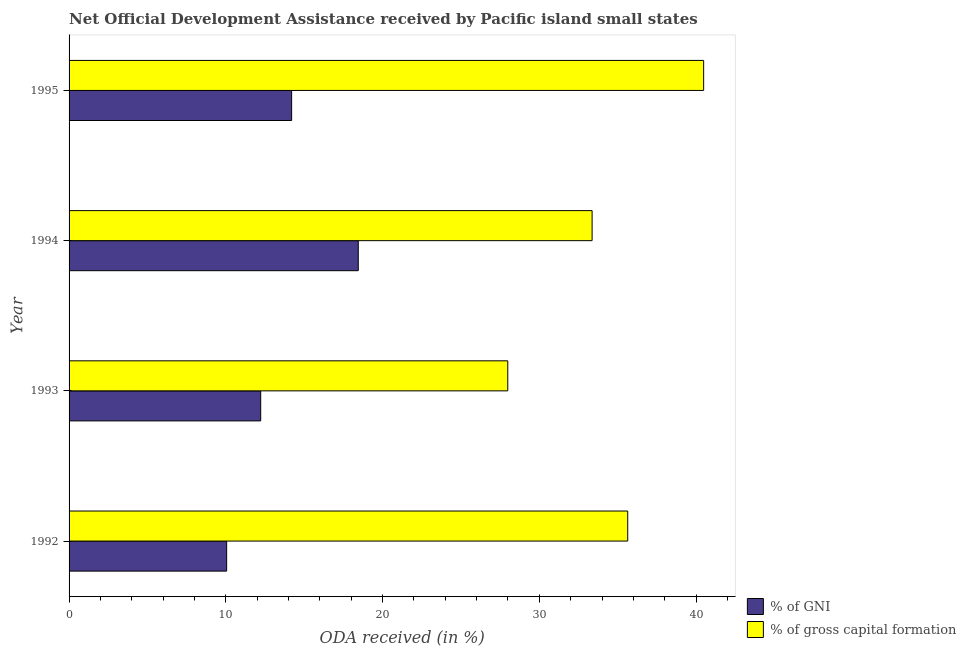How many groups of bars are there?
Your response must be concise. 4. How many bars are there on the 4th tick from the bottom?
Offer a terse response. 2. What is the label of the 1st group of bars from the top?
Offer a terse response. 1995. What is the oda received as percentage of gni in 1993?
Make the answer very short. 12.23. Across all years, what is the maximum oda received as percentage of gni?
Provide a short and direct response. 18.45. Across all years, what is the minimum oda received as percentage of gni?
Your answer should be compact. 10.05. In which year was the oda received as percentage of gross capital formation maximum?
Make the answer very short. 1995. In which year was the oda received as percentage of gross capital formation minimum?
Make the answer very short. 1993. What is the total oda received as percentage of gross capital formation in the graph?
Make the answer very short. 137.48. What is the difference between the oda received as percentage of gross capital formation in 1993 and that in 1995?
Your answer should be very brief. -12.5. What is the difference between the oda received as percentage of gross capital formation in 1995 and the oda received as percentage of gni in 1993?
Keep it short and to the point. 28.26. What is the average oda received as percentage of gni per year?
Provide a succinct answer. 13.73. In the year 1993, what is the difference between the oda received as percentage of gni and oda received as percentage of gross capital formation?
Your answer should be compact. -15.76. In how many years, is the oda received as percentage of gni greater than 6 %?
Your answer should be compact. 4. What is the ratio of the oda received as percentage of gni in 1993 to that in 1994?
Provide a short and direct response. 0.66. Is the oda received as percentage of gni in 1992 less than that in 1993?
Your response must be concise. Yes. Is the difference between the oda received as percentage of gross capital formation in 1992 and 1993 greater than the difference between the oda received as percentage of gni in 1992 and 1993?
Make the answer very short. Yes. What is the difference between the highest and the second highest oda received as percentage of gross capital formation?
Offer a very short reply. 4.84. What is the difference between the highest and the lowest oda received as percentage of gross capital formation?
Your answer should be compact. 12.5. In how many years, is the oda received as percentage of gross capital formation greater than the average oda received as percentage of gross capital formation taken over all years?
Give a very brief answer. 2. Is the sum of the oda received as percentage of gni in 1993 and 1994 greater than the maximum oda received as percentage of gross capital formation across all years?
Give a very brief answer. No. What does the 1st bar from the top in 1993 represents?
Your response must be concise. % of gross capital formation. What does the 1st bar from the bottom in 1994 represents?
Your answer should be very brief. % of GNI. What is the title of the graph?
Offer a very short reply. Net Official Development Assistance received by Pacific island small states. What is the label or title of the X-axis?
Offer a terse response. ODA received (in %). What is the label or title of the Y-axis?
Make the answer very short. Year. What is the ODA received (in %) in % of GNI in 1992?
Provide a succinct answer. 10.05. What is the ODA received (in %) of % of gross capital formation in 1992?
Provide a succinct answer. 35.64. What is the ODA received (in %) in % of GNI in 1993?
Provide a succinct answer. 12.23. What is the ODA received (in %) in % of gross capital formation in 1993?
Make the answer very short. 27.99. What is the ODA received (in %) of % of GNI in 1994?
Keep it short and to the point. 18.45. What is the ODA received (in %) in % of gross capital formation in 1994?
Provide a short and direct response. 33.37. What is the ODA received (in %) of % of GNI in 1995?
Offer a terse response. 14.2. What is the ODA received (in %) of % of gross capital formation in 1995?
Provide a short and direct response. 40.48. Across all years, what is the maximum ODA received (in %) of % of GNI?
Your answer should be very brief. 18.45. Across all years, what is the maximum ODA received (in %) of % of gross capital formation?
Provide a succinct answer. 40.48. Across all years, what is the minimum ODA received (in %) of % of GNI?
Make the answer very short. 10.05. Across all years, what is the minimum ODA received (in %) in % of gross capital formation?
Your response must be concise. 27.99. What is the total ODA received (in %) of % of GNI in the graph?
Your response must be concise. 54.93. What is the total ODA received (in %) in % of gross capital formation in the graph?
Your answer should be compact. 137.48. What is the difference between the ODA received (in %) of % of GNI in 1992 and that in 1993?
Make the answer very short. -2.17. What is the difference between the ODA received (in %) of % of gross capital formation in 1992 and that in 1993?
Give a very brief answer. 7.65. What is the difference between the ODA received (in %) in % of GNI in 1992 and that in 1994?
Your answer should be compact. -8.4. What is the difference between the ODA received (in %) of % of gross capital formation in 1992 and that in 1994?
Provide a short and direct response. 2.27. What is the difference between the ODA received (in %) in % of GNI in 1992 and that in 1995?
Ensure brevity in your answer.  -4.15. What is the difference between the ODA received (in %) of % of gross capital formation in 1992 and that in 1995?
Offer a very short reply. -4.84. What is the difference between the ODA received (in %) of % of GNI in 1993 and that in 1994?
Offer a terse response. -6.22. What is the difference between the ODA received (in %) in % of gross capital formation in 1993 and that in 1994?
Offer a very short reply. -5.38. What is the difference between the ODA received (in %) in % of GNI in 1993 and that in 1995?
Your answer should be very brief. -1.97. What is the difference between the ODA received (in %) of % of gross capital formation in 1993 and that in 1995?
Provide a succinct answer. -12.5. What is the difference between the ODA received (in %) in % of GNI in 1994 and that in 1995?
Provide a succinct answer. 4.25. What is the difference between the ODA received (in %) of % of gross capital formation in 1994 and that in 1995?
Make the answer very short. -7.11. What is the difference between the ODA received (in %) of % of GNI in 1992 and the ODA received (in %) of % of gross capital formation in 1993?
Offer a terse response. -17.93. What is the difference between the ODA received (in %) of % of GNI in 1992 and the ODA received (in %) of % of gross capital formation in 1994?
Provide a short and direct response. -23.32. What is the difference between the ODA received (in %) of % of GNI in 1992 and the ODA received (in %) of % of gross capital formation in 1995?
Provide a short and direct response. -30.43. What is the difference between the ODA received (in %) in % of GNI in 1993 and the ODA received (in %) in % of gross capital formation in 1994?
Your response must be concise. -21.14. What is the difference between the ODA received (in %) in % of GNI in 1993 and the ODA received (in %) in % of gross capital formation in 1995?
Your response must be concise. -28.26. What is the difference between the ODA received (in %) of % of GNI in 1994 and the ODA received (in %) of % of gross capital formation in 1995?
Keep it short and to the point. -22.03. What is the average ODA received (in %) in % of GNI per year?
Your response must be concise. 13.73. What is the average ODA received (in %) in % of gross capital formation per year?
Give a very brief answer. 34.37. In the year 1992, what is the difference between the ODA received (in %) in % of GNI and ODA received (in %) in % of gross capital formation?
Your answer should be compact. -25.59. In the year 1993, what is the difference between the ODA received (in %) of % of GNI and ODA received (in %) of % of gross capital formation?
Your answer should be very brief. -15.76. In the year 1994, what is the difference between the ODA received (in %) of % of GNI and ODA received (in %) of % of gross capital formation?
Your answer should be very brief. -14.92. In the year 1995, what is the difference between the ODA received (in %) of % of GNI and ODA received (in %) of % of gross capital formation?
Your response must be concise. -26.28. What is the ratio of the ODA received (in %) of % of GNI in 1992 to that in 1993?
Provide a succinct answer. 0.82. What is the ratio of the ODA received (in %) of % of gross capital formation in 1992 to that in 1993?
Make the answer very short. 1.27. What is the ratio of the ODA received (in %) in % of GNI in 1992 to that in 1994?
Give a very brief answer. 0.54. What is the ratio of the ODA received (in %) of % of gross capital formation in 1992 to that in 1994?
Offer a terse response. 1.07. What is the ratio of the ODA received (in %) of % of GNI in 1992 to that in 1995?
Ensure brevity in your answer.  0.71. What is the ratio of the ODA received (in %) of % of gross capital formation in 1992 to that in 1995?
Ensure brevity in your answer.  0.88. What is the ratio of the ODA received (in %) of % of GNI in 1993 to that in 1994?
Ensure brevity in your answer.  0.66. What is the ratio of the ODA received (in %) of % of gross capital formation in 1993 to that in 1994?
Your answer should be very brief. 0.84. What is the ratio of the ODA received (in %) in % of GNI in 1993 to that in 1995?
Your answer should be very brief. 0.86. What is the ratio of the ODA received (in %) in % of gross capital formation in 1993 to that in 1995?
Provide a succinct answer. 0.69. What is the ratio of the ODA received (in %) of % of GNI in 1994 to that in 1995?
Offer a terse response. 1.3. What is the ratio of the ODA received (in %) of % of gross capital formation in 1994 to that in 1995?
Keep it short and to the point. 0.82. What is the difference between the highest and the second highest ODA received (in %) in % of GNI?
Your response must be concise. 4.25. What is the difference between the highest and the second highest ODA received (in %) of % of gross capital formation?
Keep it short and to the point. 4.84. What is the difference between the highest and the lowest ODA received (in %) in % of GNI?
Offer a very short reply. 8.4. What is the difference between the highest and the lowest ODA received (in %) in % of gross capital formation?
Ensure brevity in your answer.  12.5. 